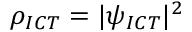Convert formula to latex. <formula><loc_0><loc_0><loc_500><loc_500>\rho _ { I C T } = | \psi _ { I C T } | ^ { 2 }</formula> 